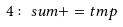<formula> <loc_0><loc_0><loc_500><loc_500>4 \colon s u m + = t m p</formula> 